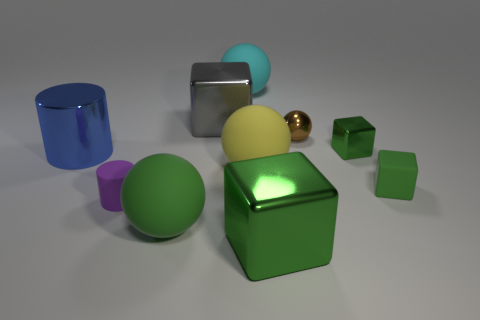Subtract all blue spheres. How many green cubes are left? 3 Subtract all balls. How many objects are left? 6 Add 1 blue metallic things. How many blue metallic things are left? 2 Add 6 big purple metal spheres. How many big purple metal spheres exist? 6 Subtract 1 blue cylinders. How many objects are left? 9 Subtract all tiny green rubber things. Subtract all gray metallic things. How many objects are left? 8 